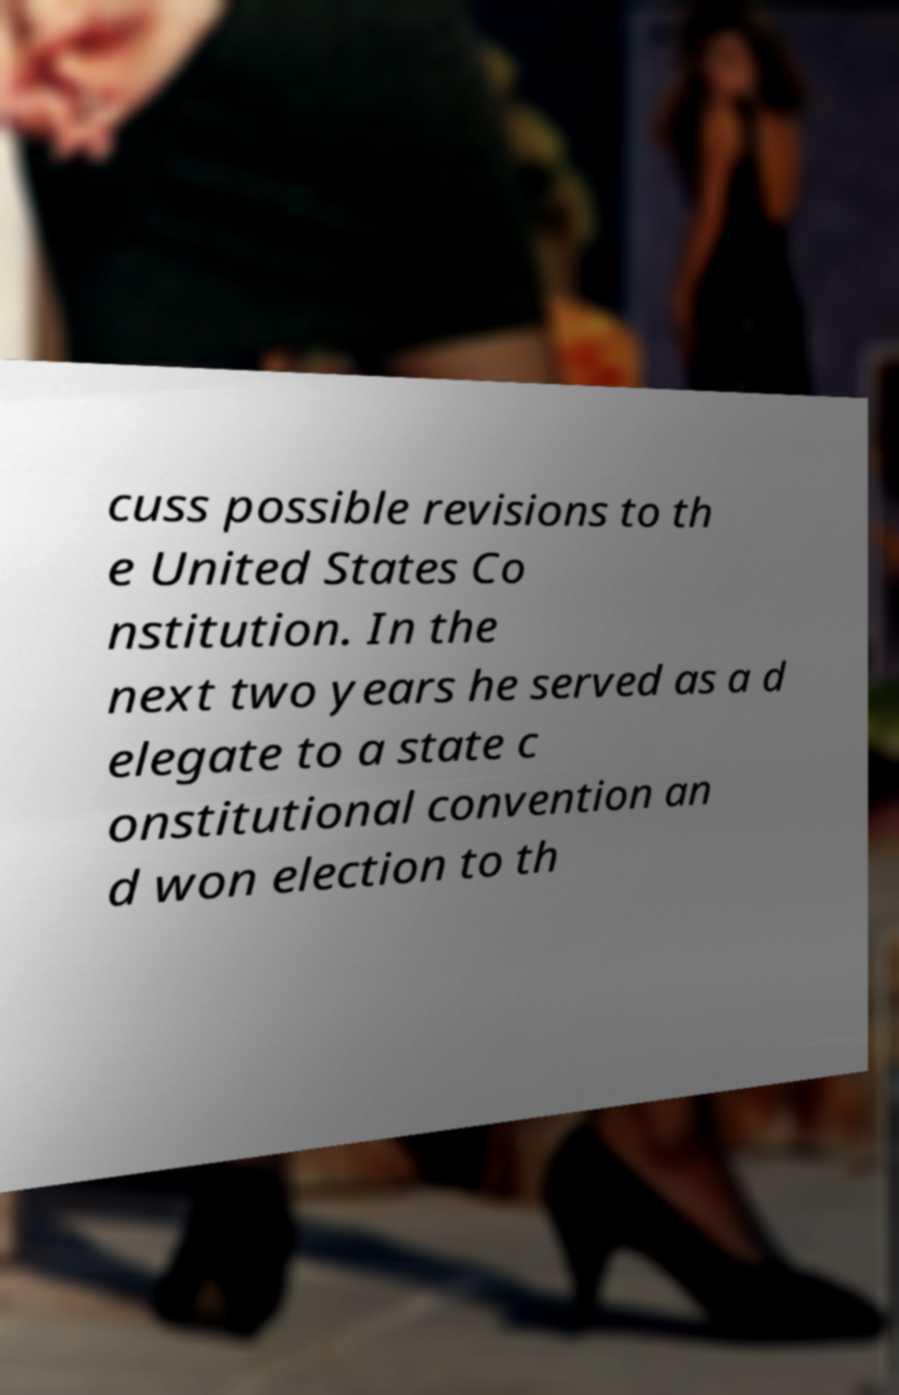What messages or text are displayed in this image? I need them in a readable, typed format. cuss possible revisions to th e United States Co nstitution. In the next two years he served as a d elegate to a state c onstitutional convention an d won election to th 